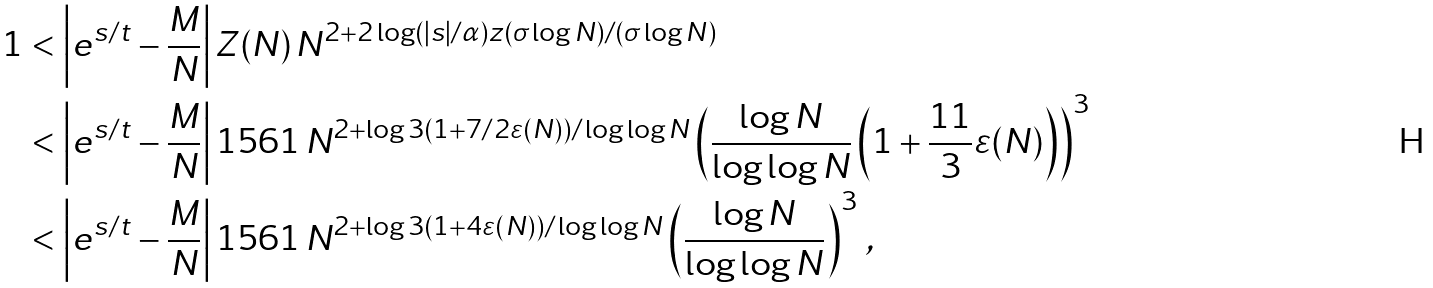<formula> <loc_0><loc_0><loc_500><loc_500>1 & < \left | e ^ { s / t } - \frac { M } { N } \right | Z ( N ) \, N ^ { 2 + 2 \log ( | s | / \alpha ) z ( \sigma \log N ) / ( \sigma \log N ) } \\ & < \left | e ^ { s / t } - \frac { M } { N } \right | 1 5 6 1 \, N ^ { 2 + \log 3 ( 1 + 7 / 2 \varepsilon ( N ) ) / \log \log N } \left ( \frac { \log N } { \log \log N } \left ( 1 + \frac { 1 1 } { 3 } \varepsilon ( N ) \right ) \right ) ^ { 3 } \\ & < \left | e ^ { s / t } - \frac { M } { N } \right | 1 5 6 1 \, N ^ { 2 + \log 3 ( 1 + 4 \varepsilon ( N ) ) / \log \log N } \left ( \frac { \log N } { \log \log N } \right ) ^ { 3 } \, ,</formula> 